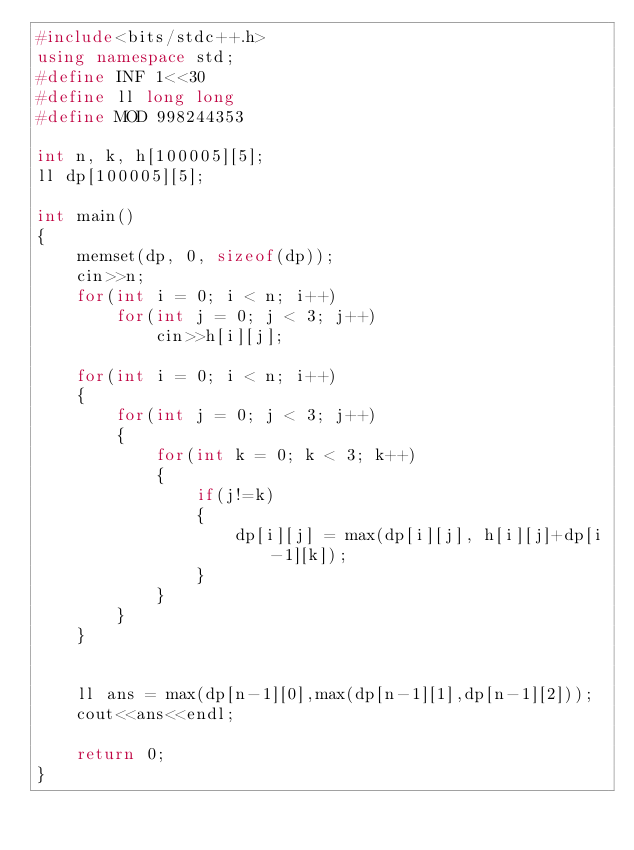<code> <loc_0><loc_0><loc_500><loc_500><_C++_>#include<bits/stdc++.h>
using namespace std;
#define INF 1<<30
#define ll long long
#define MOD 998244353

int n, k, h[100005][5];
ll dp[100005][5];

int main()
{
    memset(dp, 0, sizeof(dp));
    cin>>n;
    for(int i = 0; i < n; i++)
        for(int j = 0; j < 3; j++)
            cin>>h[i][j];

    for(int i = 0; i < n; i++)
    {
        for(int j = 0; j < 3; j++)
        {
            for(int k = 0; k < 3; k++)
            {
                if(j!=k)
                {
                    dp[i][j] = max(dp[i][j], h[i][j]+dp[i-1][k]);
                }
            }
        }
    }


    ll ans = max(dp[n-1][0],max(dp[n-1][1],dp[n-1][2]));
    cout<<ans<<endl;

    return 0;
}
</code> 